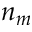Convert formula to latex. <formula><loc_0><loc_0><loc_500><loc_500>n _ { m }</formula> 